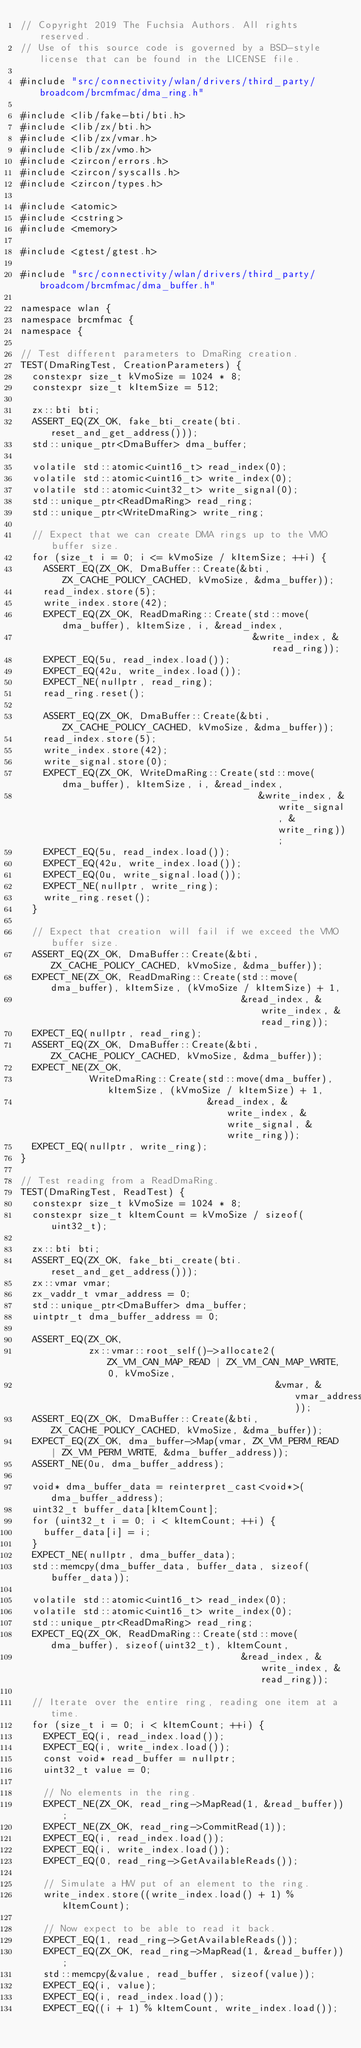Convert code to text. <code><loc_0><loc_0><loc_500><loc_500><_C++_>// Copyright 2019 The Fuchsia Authors. All rights reserved.
// Use of this source code is governed by a BSD-style license that can be found in the LICENSE file.

#include "src/connectivity/wlan/drivers/third_party/broadcom/brcmfmac/dma_ring.h"

#include <lib/fake-bti/bti.h>
#include <lib/zx/bti.h>
#include <lib/zx/vmar.h>
#include <lib/zx/vmo.h>
#include <zircon/errors.h>
#include <zircon/syscalls.h>
#include <zircon/types.h>

#include <atomic>
#include <cstring>
#include <memory>

#include <gtest/gtest.h>

#include "src/connectivity/wlan/drivers/third_party/broadcom/brcmfmac/dma_buffer.h"

namespace wlan {
namespace brcmfmac {
namespace {

// Test different parameters to DmaRing creation.
TEST(DmaRingTest, CreationParameters) {
  constexpr size_t kVmoSize = 1024 * 8;
  constexpr size_t kItemSize = 512;

  zx::bti bti;
  ASSERT_EQ(ZX_OK, fake_bti_create(bti.reset_and_get_address()));
  std::unique_ptr<DmaBuffer> dma_buffer;

  volatile std::atomic<uint16_t> read_index(0);
  volatile std::atomic<uint16_t> write_index(0);
  volatile std::atomic<uint32_t> write_signal(0);
  std::unique_ptr<ReadDmaRing> read_ring;
  std::unique_ptr<WriteDmaRing> write_ring;

  // Expect that we can create DMA rings up to the VMO buffer size.
  for (size_t i = 0; i <= kVmoSize / kItemSize; ++i) {
    ASSERT_EQ(ZX_OK, DmaBuffer::Create(&bti, ZX_CACHE_POLICY_CACHED, kVmoSize, &dma_buffer));
    read_index.store(5);
    write_index.store(42);
    EXPECT_EQ(ZX_OK, ReadDmaRing::Create(std::move(dma_buffer), kItemSize, i, &read_index,
                                         &write_index, &read_ring));
    EXPECT_EQ(5u, read_index.load());
    EXPECT_EQ(42u, write_index.load());
    EXPECT_NE(nullptr, read_ring);
    read_ring.reset();

    ASSERT_EQ(ZX_OK, DmaBuffer::Create(&bti, ZX_CACHE_POLICY_CACHED, kVmoSize, &dma_buffer));
    read_index.store(5);
    write_index.store(42);
    write_signal.store(0);
    EXPECT_EQ(ZX_OK, WriteDmaRing::Create(std::move(dma_buffer), kItemSize, i, &read_index,
                                          &write_index, &write_signal, &write_ring));
    EXPECT_EQ(5u, read_index.load());
    EXPECT_EQ(42u, write_index.load());
    EXPECT_EQ(0u, write_signal.load());
    EXPECT_NE(nullptr, write_ring);
    write_ring.reset();
  }

  // Expect that creation will fail if we exceed the VMO buffer size.
  ASSERT_EQ(ZX_OK, DmaBuffer::Create(&bti, ZX_CACHE_POLICY_CACHED, kVmoSize, &dma_buffer));
  EXPECT_NE(ZX_OK, ReadDmaRing::Create(std::move(dma_buffer), kItemSize, (kVmoSize / kItemSize) + 1,
                                       &read_index, &write_index, &read_ring));
  EXPECT_EQ(nullptr, read_ring);
  ASSERT_EQ(ZX_OK, DmaBuffer::Create(&bti, ZX_CACHE_POLICY_CACHED, kVmoSize, &dma_buffer));
  EXPECT_NE(ZX_OK,
            WriteDmaRing::Create(std::move(dma_buffer), kItemSize, (kVmoSize / kItemSize) + 1,
                                 &read_index, &write_index, &write_signal, &write_ring));
  EXPECT_EQ(nullptr, write_ring);
}

// Test reading from a ReadDmaRing.
TEST(DmaRingTest, ReadTest) {
  constexpr size_t kVmoSize = 1024 * 8;
  constexpr size_t kItemCount = kVmoSize / sizeof(uint32_t);

  zx::bti bti;
  ASSERT_EQ(ZX_OK, fake_bti_create(bti.reset_and_get_address()));
  zx::vmar vmar;
  zx_vaddr_t vmar_address = 0;
  std::unique_ptr<DmaBuffer> dma_buffer;
  uintptr_t dma_buffer_address = 0;

  ASSERT_EQ(ZX_OK,
            zx::vmar::root_self()->allocate2(ZX_VM_CAN_MAP_READ | ZX_VM_CAN_MAP_WRITE, 0, kVmoSize,
                                             &vmar, &vmar_address));
  ASSERT_EQ(ZX_OK, DmaBuffer::Create(&bti, ZX_CACHE_POLICY_CACHED, kVmoSize, &dma_buffer));
  EXPECT_EQ(ZX_OK, dma_buffer->Map(vmar, ZX_VM_PERM_READ | ZX_VM_PERM_WRITE, &dma_buffer_address));
  ASSERT_NE(0u, dma_buffer_address);

  void* dma_buffer_data = reinterpret_cast<void*>(dma_buffer_address);
  uint32_t buffer_data[kItemCount];
  for (uint32_t i = 0; i < kItemCount; ++i) {
    buffer_data[i] = i;
  }
  EXPECT_NE(nullptr, dma_buffer_data);
  std::memcpy(dma_buffer_data, buffer_data, sizeof(buffer_data));

  volatile std::atomic<uint16_t> read_index(0);
  volatile std::atomic<uint16_t> write_index(0);
  std::unique_ptr<ReadDmaRing> read_ring;
  EXPECT_EQ(ZX_OK, ReadDmaRing::Create(std::move(dma_buffer), sizeof(uint32_t), kItemCount,
                                       &read_index, &write_index, &read_ring));

  // Iterate over the entire ring, reading one item at a time.
  for (size_t i = 0; i < kItemCount; ++i) {
    EXPECT_EQ(i, read_index.load());
    EXPECT_EQ(i, write_index.load());
    const void* read_buffer = nullptr;
    uint32_t value = 0;

    // No elements in the ring.
    EXPECT_NE(ZX_OK, read_ring->MapRead(1, &read_buffer));
    EXPECT_NE(ZX_OK, read_ring->CommitRead(1));
    EXPECT_EQ(i, read_index.load());
    EXPECT_EQ(i, write_index.load());
    EXPECT_EQ(0, read_ring->GetAvailableReads());

    // Simulate a HW put of an element to the ring.
    write_index.store((write_index.load() + 1) % kItemCount);

    // Now expect to be able to read it back.
    EXPECT_EQ(1, read_ring->GetAvailableReads());
    EXPECT_EQ(ZX_OK, read_ring->MapRead(1, &read_buffer));
    std::memcpy(&value, read_buffer, sizeof(value));
    EXPECT_EQ(i, value);
    EXPECT_EQ(i, read_index.load());
    EXPECT_EQ((i + 1) % kItemCount, write_index.load());
</code> 